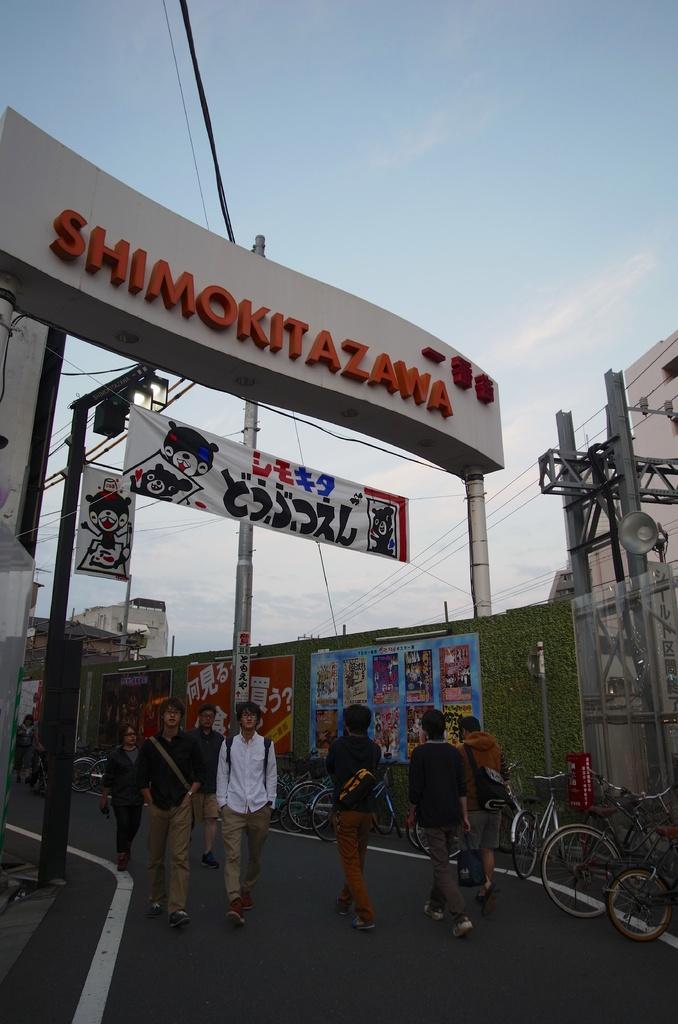Describe this image in one or two sentences. In the image we can see there are people walking. They are wearing clothes and shoes. We can see there are even bicycles. Here we can see pole, board, electric wires, building and cloudy pale blue sky. 